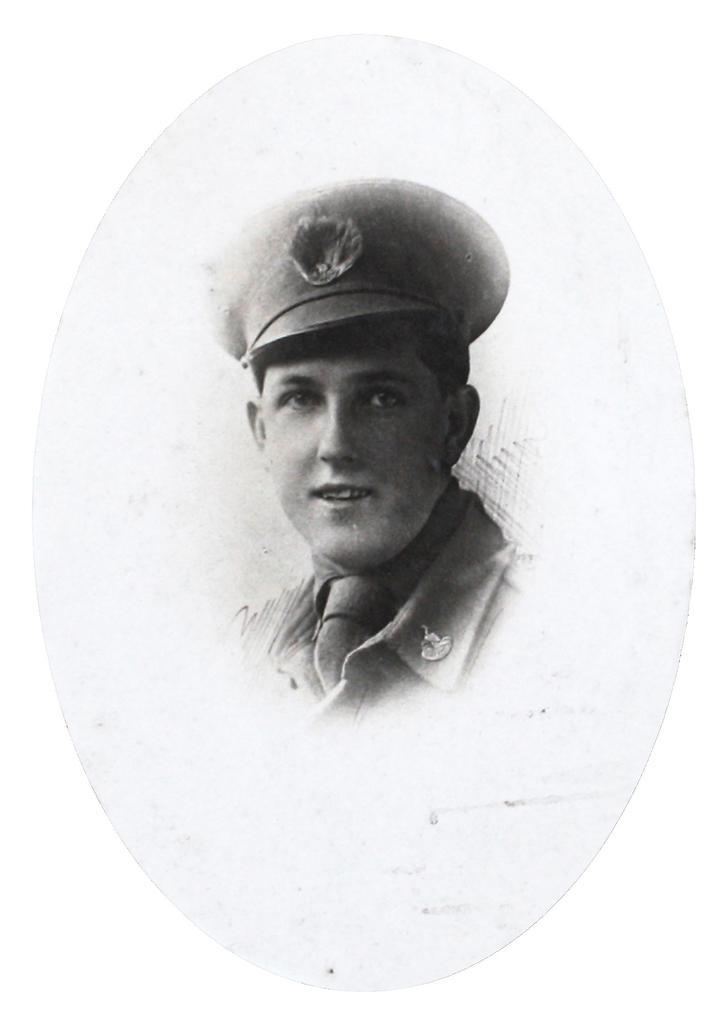Can you describe this image briefly? In the image we can see a person and he is smiling. 